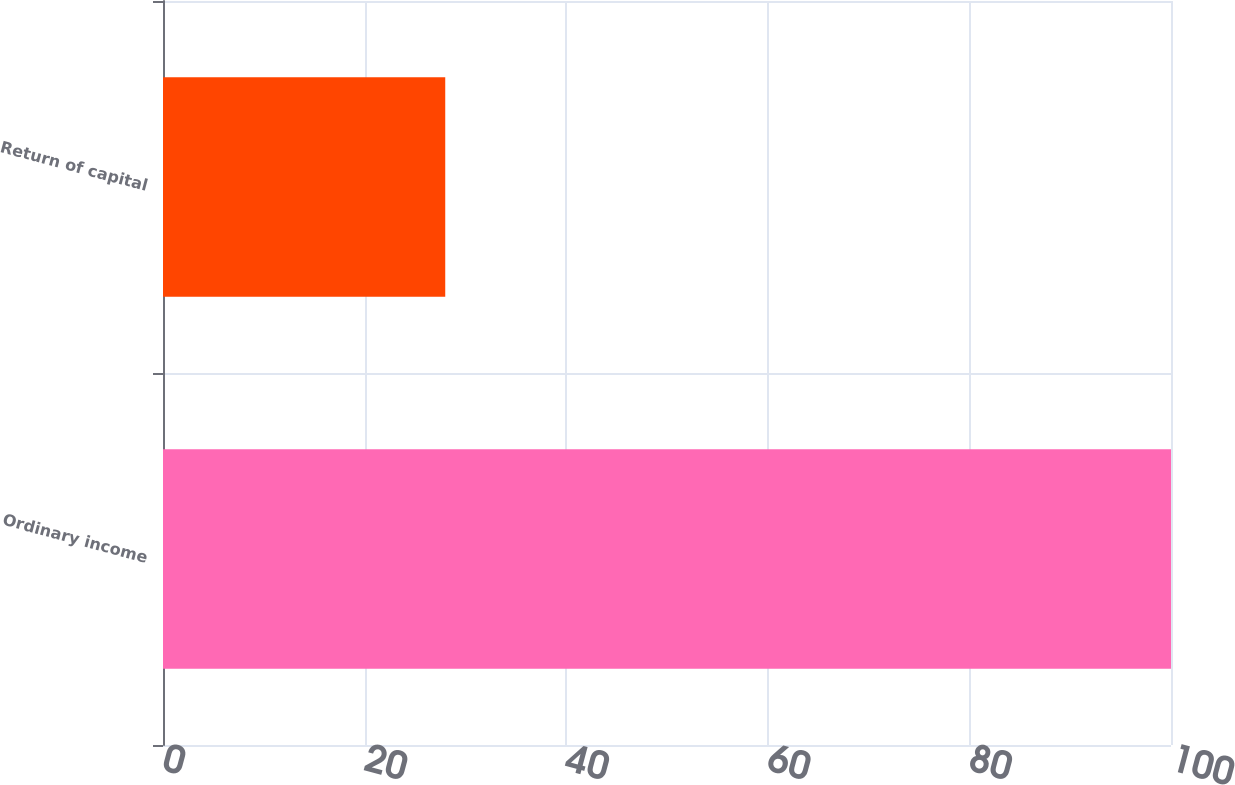<chart> <loc_0><loc_0><loc_500><loc_500><bar_chart><fcel>Ordinary income<fcel>Return of capital<nl><fcel>100<fcel>28<nl></chart> 